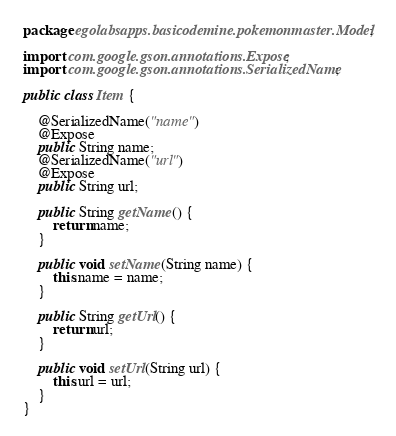Convert code to text. <code><loc_0><loc_0><loc_500><loc_500><_Java_>package egolabsapps.basicodemine.pokemonmaster.Model;

import com.google.gson.annotations.Expose;
import com.google.gson.annotations.SerializedName;

public class Item {

    @SerializedName("name")
    @Expose
    public String name;
    @SerializedName("url")
    @Expose
    public String url;

    public String getName() {
        return name;
    }

    public void setName(String name) {
        this.name = name;
    }

    public String getUrl() {
        return url;
    }

    public void setUrl(String url) {
        this.url = url;
    }
}
</code> 